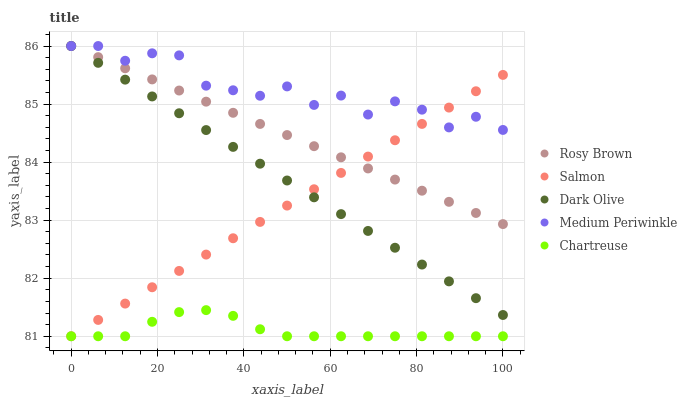Does Chartreuse have the minimum area under the curve?
Answer yes or no. Yes. Does Medium Periwinkle have the maximum area under the curve?
Answer yes or no. Yes. Does Medium Periwinkle have the minimum area under the curve?
Answer yes or no. No. Does Chartreuse have the maximum area under the curve?
Answer yes or no. No. Is Rosy Brown the smoothest?
Answer yes or no. Yes. Is Medium Periwinkle the roughest?
Answer yes or no. Yes. Is Chartreuse the smoothest?
Answer yes or no. No. Is Chartreuse the roughest?
Answer yes or no. No. Does Chartreuse have the lowest value?
Answer yes or no. Yes. Does Medium Periwinkle have the lowest value?
Answer yes or no. No. Does Rosy Brown have the highest value?
Answer yes or no. Yes. Does Chartreuse have the highest value?
Answer yes or no. No. Is Chartreuse less than Dark Olive?
Answer yes or no. Yes. Is Rosy Brown greater than Chartreuse?
Answer yes or no. Yes. Does Salmon intersect Rosy Brown?
Answer yes or no. Yes. Is Salmon less than Rosy Brown?
Answer yes or no. No. Is Salmon greater than Rosy Brown?
Answer yes or no. No. Does Chartreuse intersect Dark Olive?
Answer yes or no. No. 